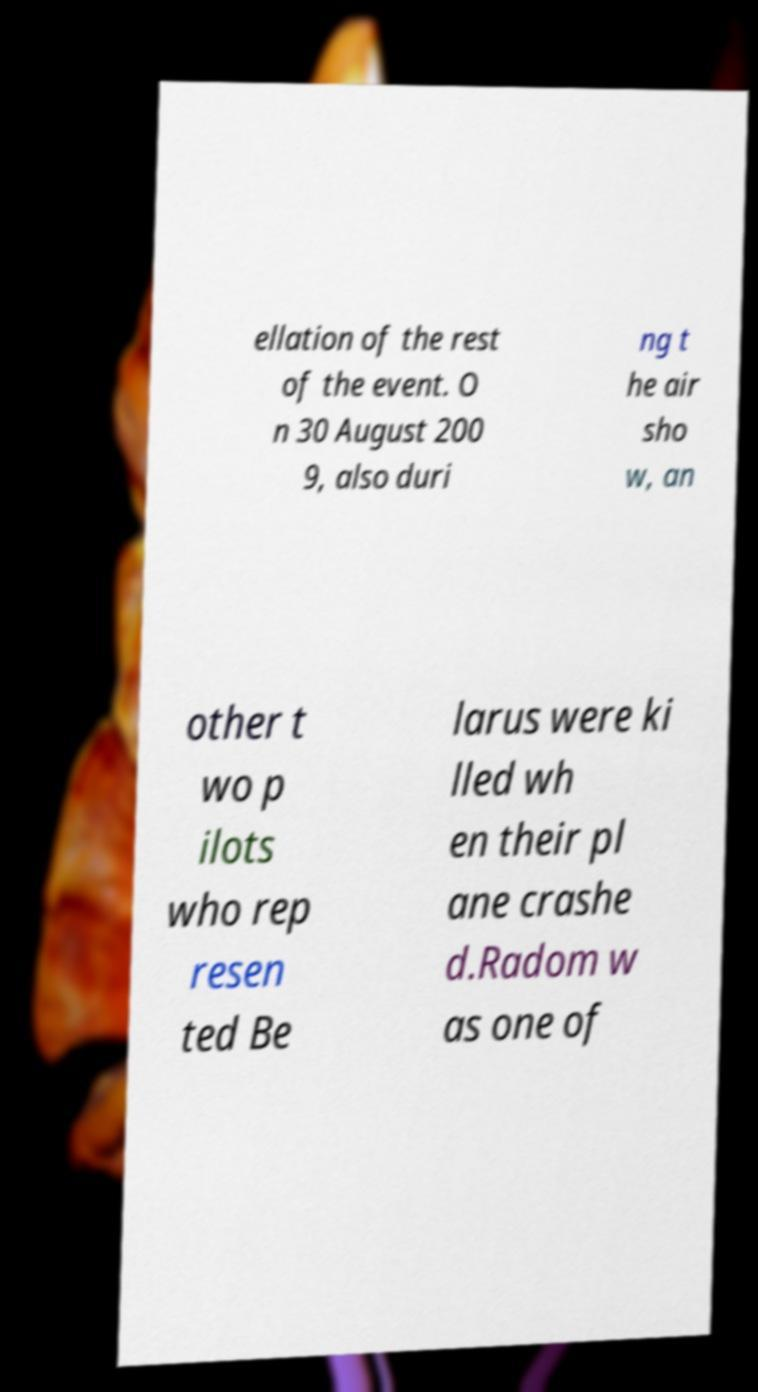Please read and relay the text visible in this image. What does it say? ellation of the rest of the event. O n 30 August 200 9, also duri ng t he air sho w, an other t wo p ilots who rep resen ted Be larus were ki lled wh en their pl ane crashe d.Radom w as one of 